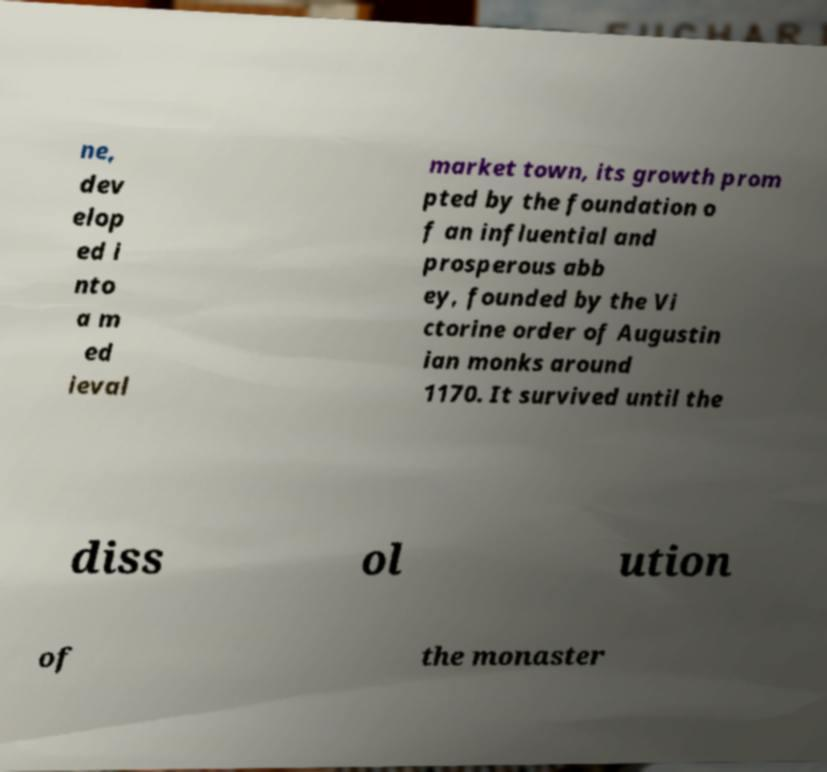There's text embedded in this image that I need extracted. Can you transcribe it verbatim? ne, dev elop ed i nto a m ed ieval market town, its growth prom pted by the foundation o f an influential and prosperous abb ey, founded by the Vi ctorine order of Augustin ian monks around 1170. It survived until the diss ol ution of the monaster 